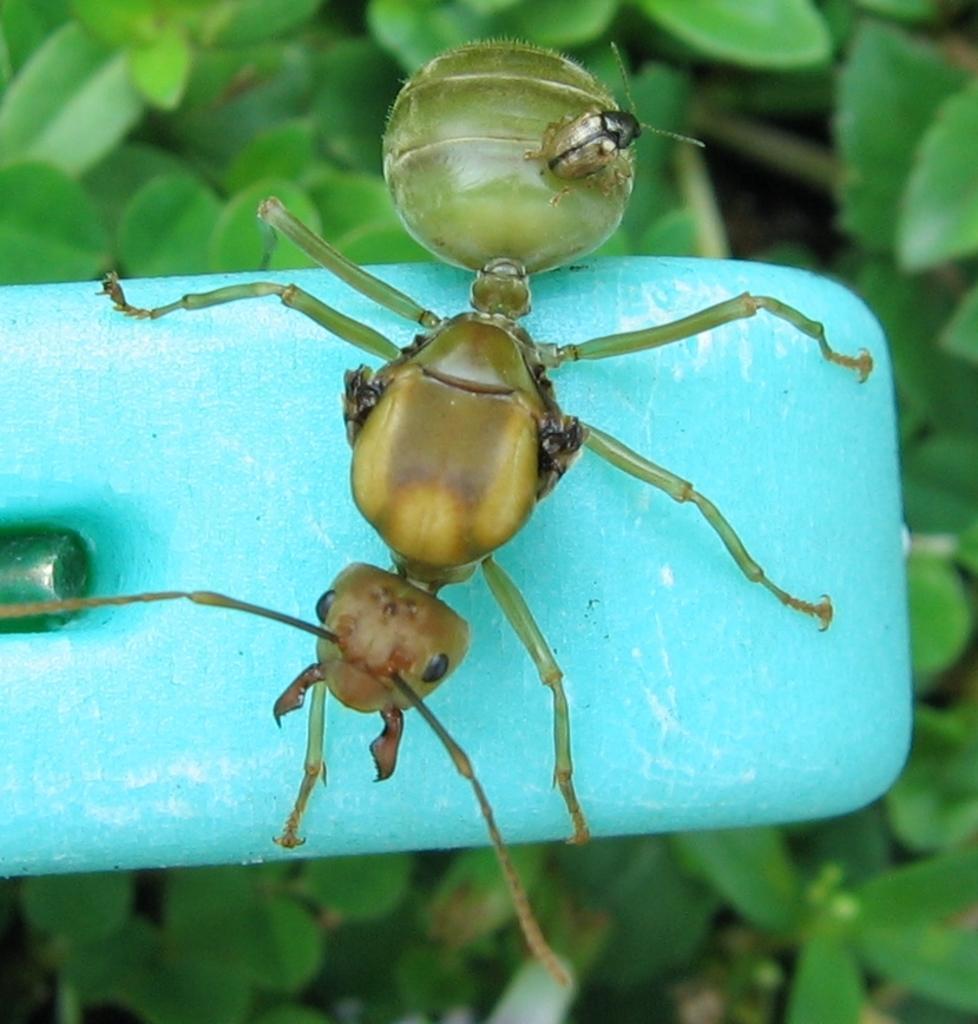Can you describe this image briefly? In this image, we can see an ant on blue color object. In the background of the image, there are some leaves. 